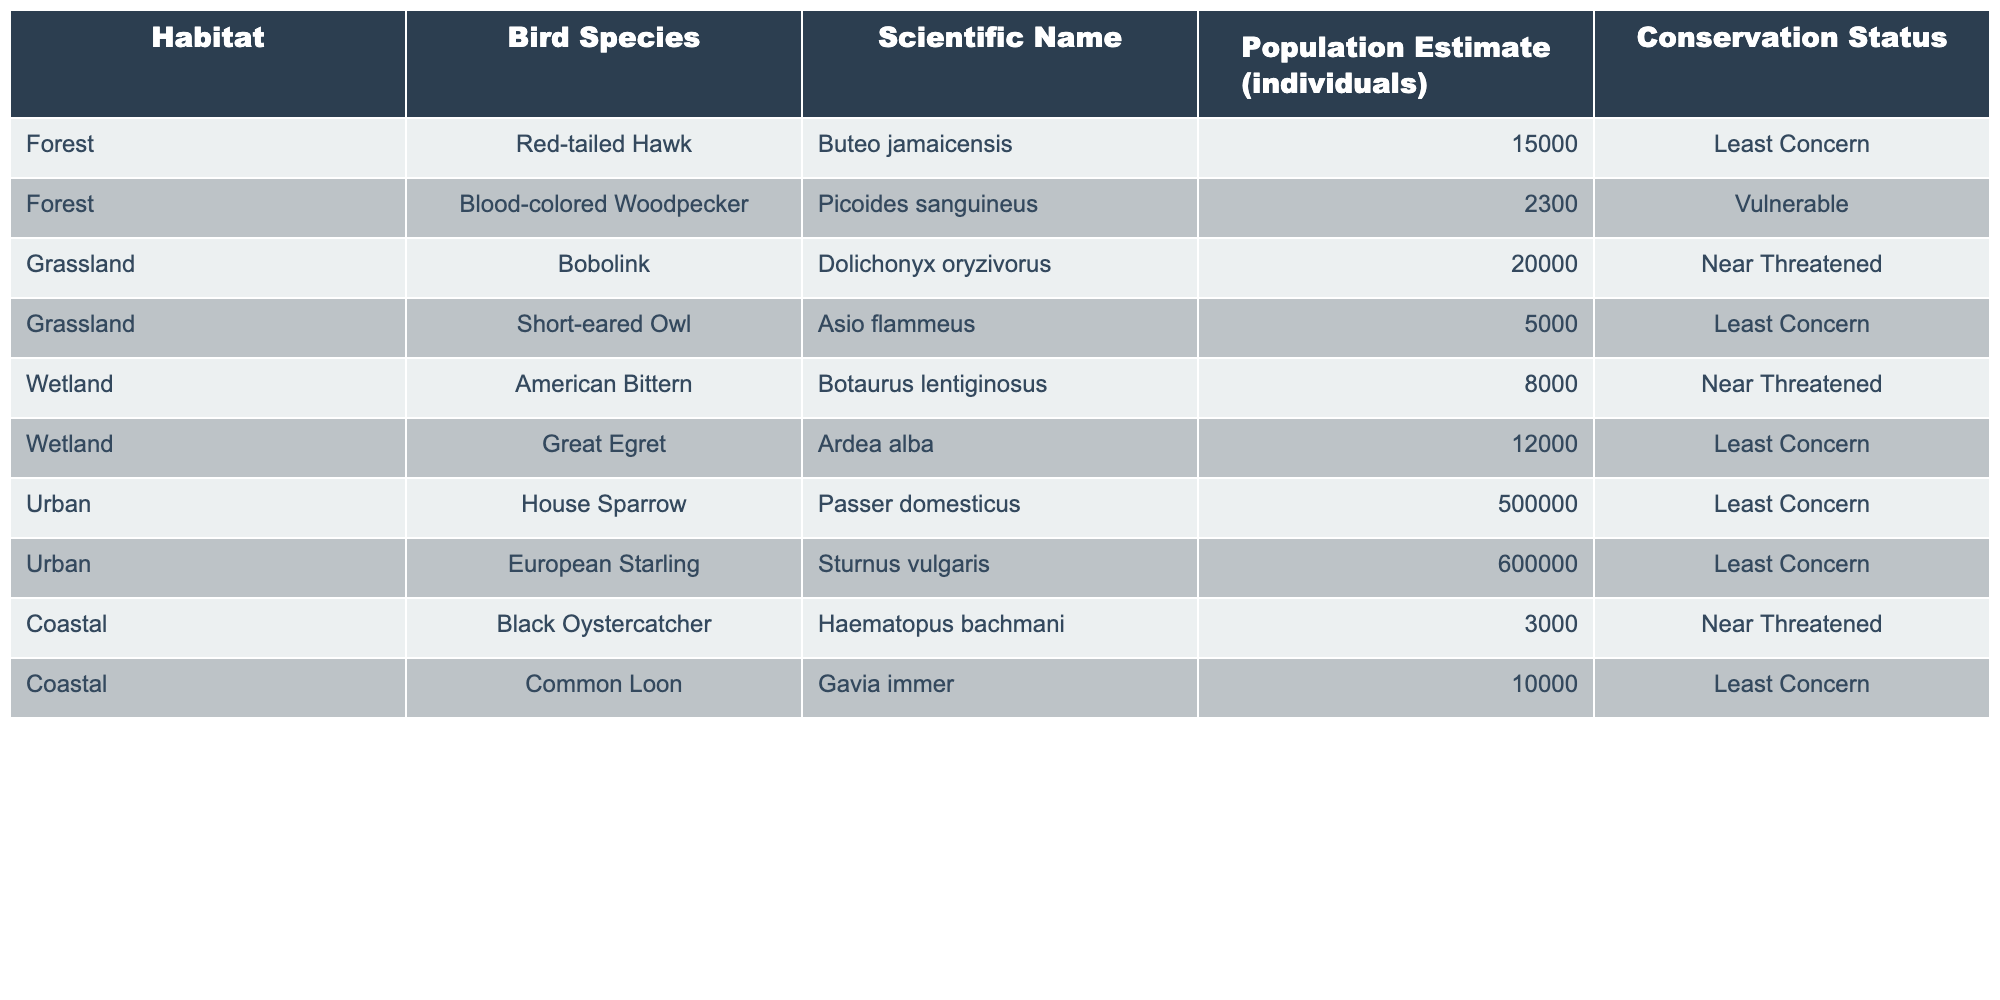What is the population estimate of the House Sparrow? The table lists the House Sparrow under the Urban habitat with a population estimate of 500,000 individuals.
Answer: 500,000 How many bird species are listed in the Wetland habitat? There are 2 bird species in the Wetland habitat: American Bittern and Great Egret.
Answer: 2 Which bird species has the highest population estimate? The House Sparrow is listed with the highest population estimate of 500,000 individuals, compared to other species.
Answer: House Sparrow What is the conservation status of the Blood-colored Woodpecker? The conservation status for the Blood-colored Woodpecker in the table is listed as Vulnerable.
Answer: Vulnerable How many individuals are estimated for the Red-tailed Hawk and the Great Egret combined? The Red-tailed Hawk has an estimate of 15,000 individuals and the Great Egret has 12,000. Combined, this is 15,000 + 12,000 = 27,000.
Answer: 27,000 Is the population estimate of the Short-eared Owl above 5,000? The population estimate for the Short-eared Owl is exactly 5,000, so it is not above 5,000.
Answer: No What is the difference in population estimates between the European Starling and the Black Oystercatcher? The European Starling has a population estimate of 600,000, while the Black Oystercatcher has 3,000. The difference is 600,000 - 3,000 = 597,000.
Answer: 597,000 Which habitat has the least number of bird species listed? The Coastal habitat only has 2 bird species: Black Oystercatcher and Common Loon, which is the least compared to others.
Answer: Coastal What is the average population estimate of bird species in the Grassland habitat? The Grassland has two species: Bobolink (20,000) and Short-eared Owl (5,000). The average is (20,000 + 5,000) / 2 = 12,500.
Answer: 12,500 Is the American Bittern considered Least Concern? The conservation status of the American Bittern is Near Threatened, which means it is not considered Least Concern.
Answer: No What percentage of the total population estimates is attributed to Urban habitat species? Adding up the Urban habitat species: House Sparrow (500,000) + European Starling (600,000) gives a total of 1,100,000. The total population of all species is 1,100,000 + 15,000 + 2,300 + 20,000 + 5,000 + 8,000 + 12,000 + 3,000 + 10,000 = 1,200,600. Thus, the percentage is (1,100,000 / 1,200,600) * 100 ≈ 91.65%.
Answer: 91.65% 